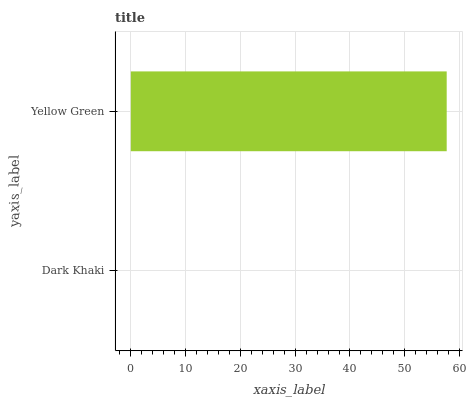Is Dark Khaki the minimum?
Answer yes or no. Yes. Is Yellow Green the maximum?
Answer yes or no. Yes. Is Yellow Green the minimum?
Answer yes or no. No. Is Yellow Green greater than Dark Khaki?
Answer yes or no. Yes. Is Dark Khaki less than Yellow Green?
Answer yes or no. Yes. Is Dark Khaki greater than Yellow Green?
Answer yes or no. No. Is Yellow Green less than Dark Khaki?
Answer yes or no. No. Is Yellow Green the high median?
Answer yes or no. Yes. Is Dark Khaki the low median?
Answer yes or no. Yes. Is Dark Khaki the high median?
Answer yes or no. No. Is Yellow Green the low median?
Answer yes or no. No. 